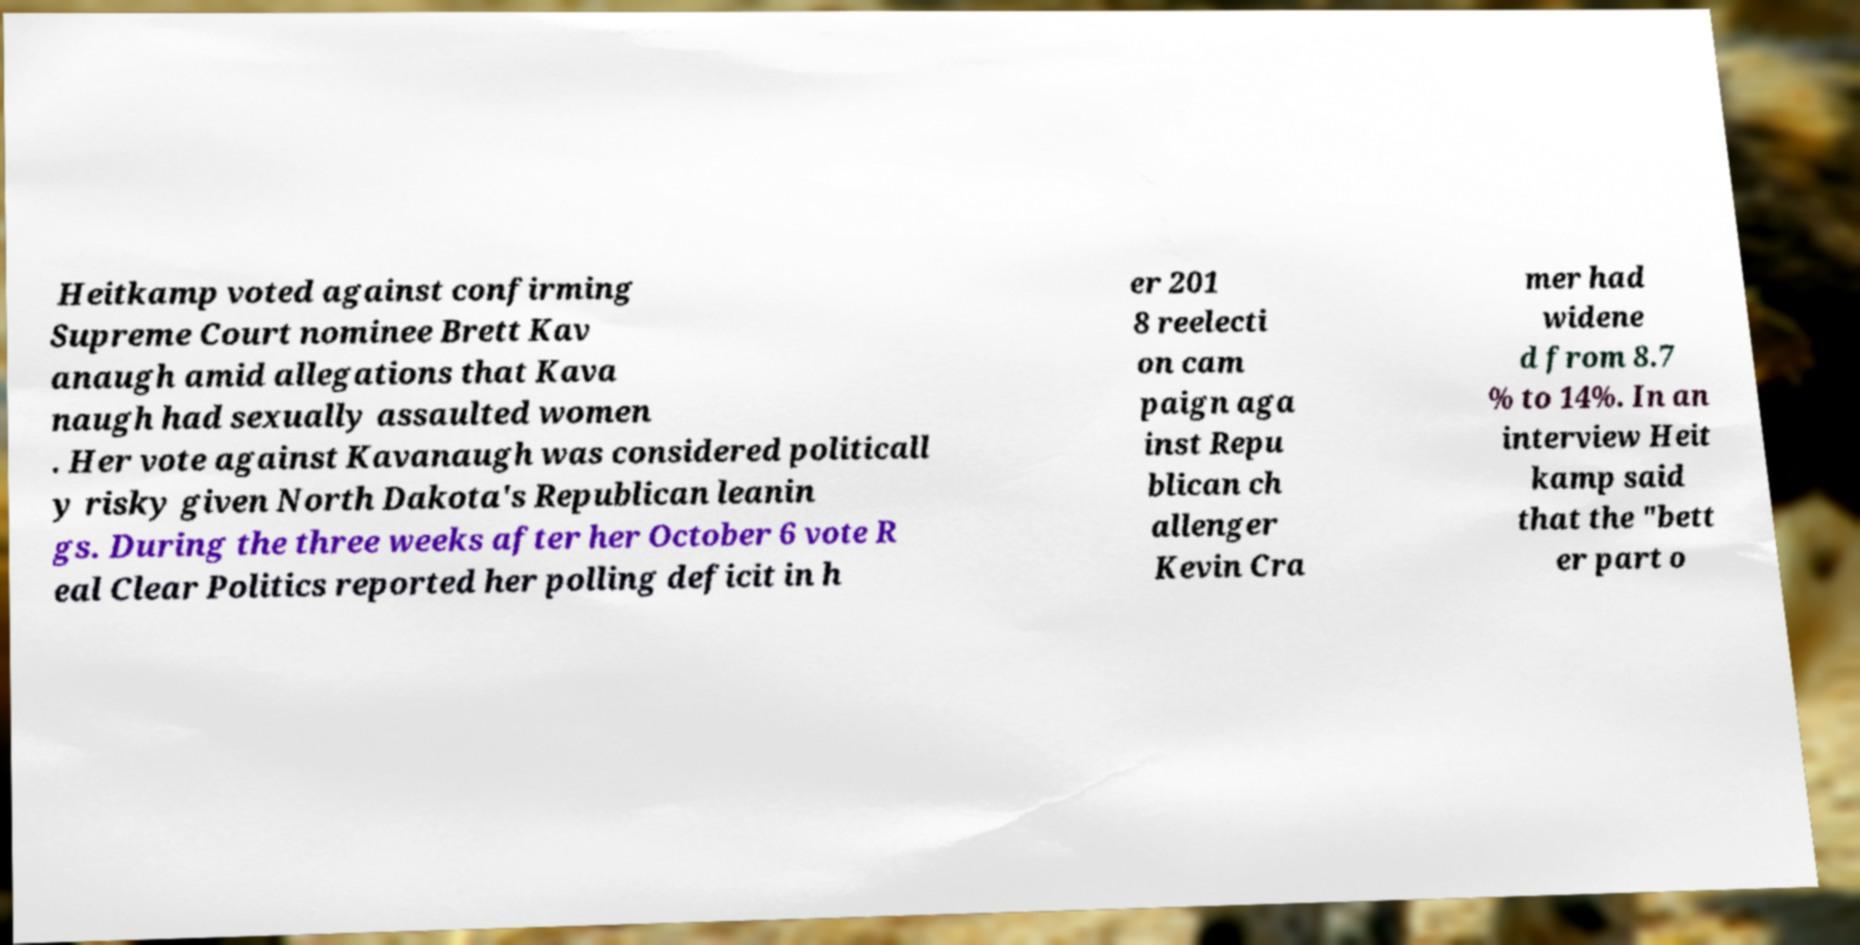I need the written content from this picture converted into text. Can you do that? Heitkamp voted against confirming Supreme Court nominee Brett Kav anaugh amid allegations that Kava naugh had sexually assaulted women . Her vote against Kavanaugh was considered politicall y risky given North Dakota's Republican leanin gs. During the three weeks after her October 6 vote R eal Clear Politics reported her polling deficit in h er 201 8 reelecti on cam paign aga inst Repu blican ch allenger Kevin Cra mer had widene d from 8.7 % to 14%. In an interview Heit kamp said that the "bett er part o 